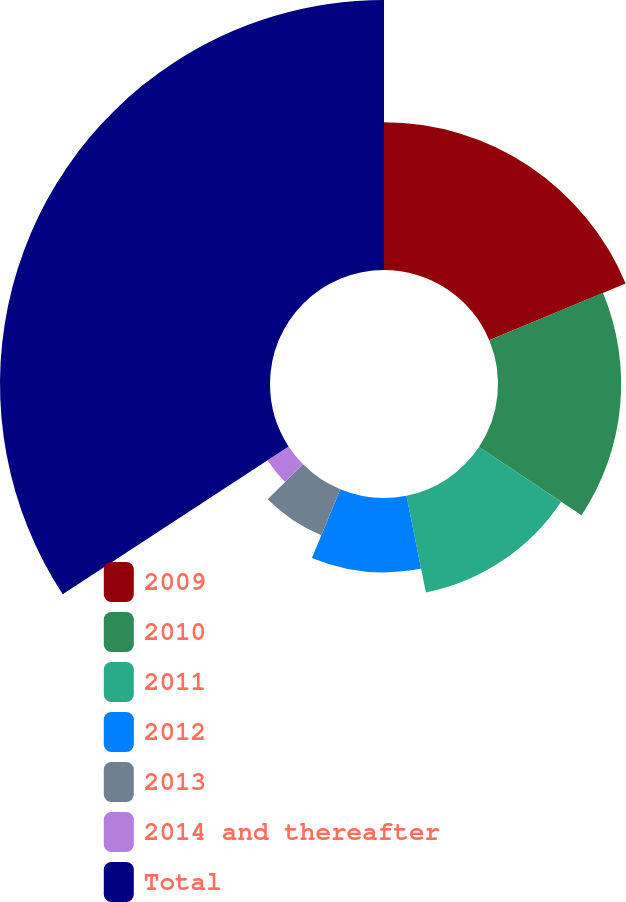<chart> <loc_0><loc_0><loc_500><loc_500><pie_chart><fcel>2009<fcel>2010<fcel>2011<fcel>2012<fcel>2013<fcel>2014 and thereafter<fcel>Total<nl><fcel>18.72%<fcel>15.61%<fcel>12.51%<fcel>9.41%<fcel>6.31%<fcel>3.21%<fcel>34.22%<nl></chart> 